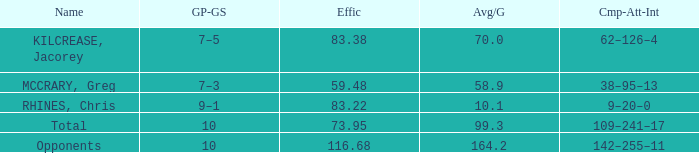What is the avg/g of Rhines, Chris, who has an effic greater than 73.95? 10.1. 